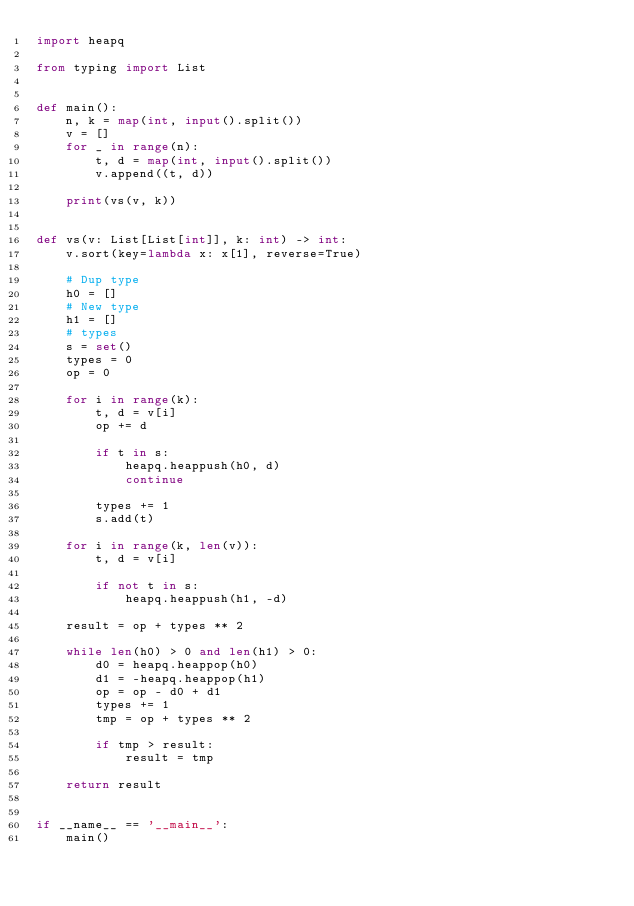Convert code to text. <code><loc_0><loc_0><loc_500><loc_500><_Python_>import heapq

from typing import List


def main():
    n, k = map(int, input().split())
    v = []
    for _ in range(n):
        t, d = map(int, input().split())
        v.append((t, d))

    print(vs(v, k))


def vs(v: List[List[int]], k: int) -> int:
    v.sort(key=lambda x: x[1], reverse=True)

    # Dup type
    h0 = []
    # New type
    h1 = []
    # types
    s = set()
    types = 0
    op = 0

    for i in range(k):
        t, d = v[i]
        op += d

        if t in s:
            heapq.heappush(h0, d)
            continue

        types += 1
        s.add(t)

    for i in range(k, len(v)):
        t, d = v[i]

        if not t in s:
            heapq.heappush(h1, -d)

    result = op + types ** 2

    while len(h0) > 0 and len(h1) > 0:
        d0 = heapq.heappop(h0)
        d1 = -heapq.heappop(h1)
        op = op - d0 + d1
        types += 1
        tmp = op + types ** 2

        if tmp > result:
            result = tmp

    return result


if __name__ == '__main__':
    main()
</code> 